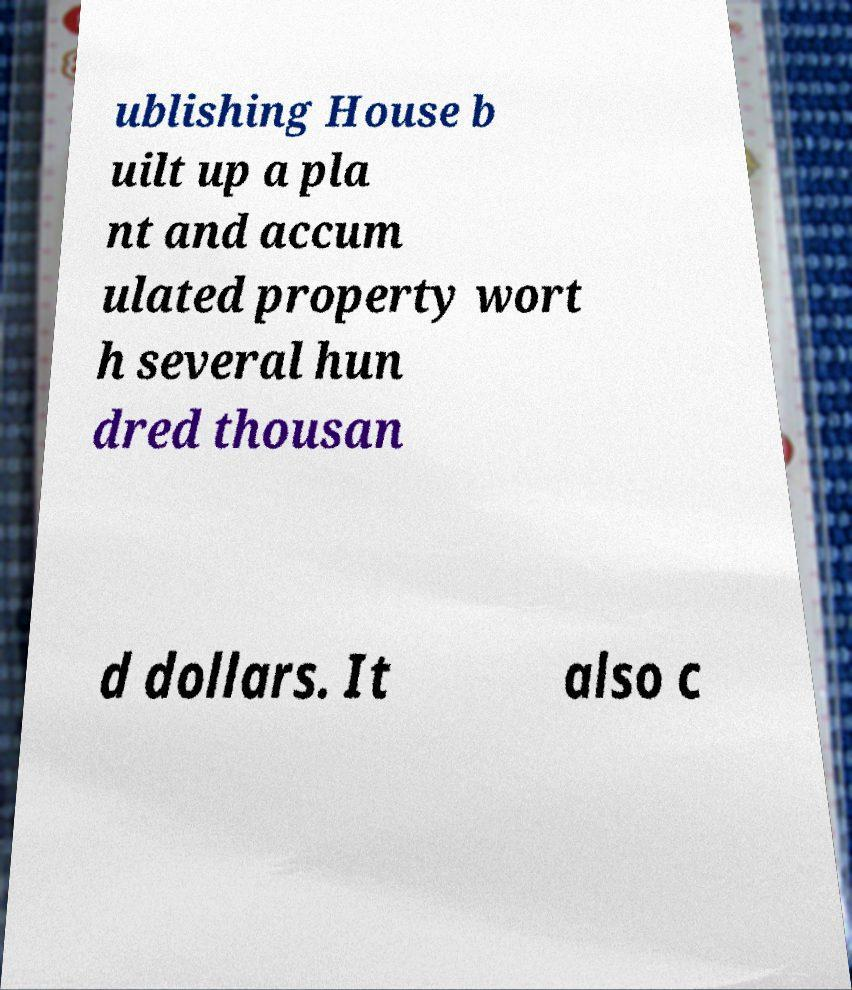There's text embedded in this image that I need extracted. Can you transcribe it verbatim? ublishing House b uilt up a pla nt and accum ulated property wort h several hun dred thousan d dollars. It also c 